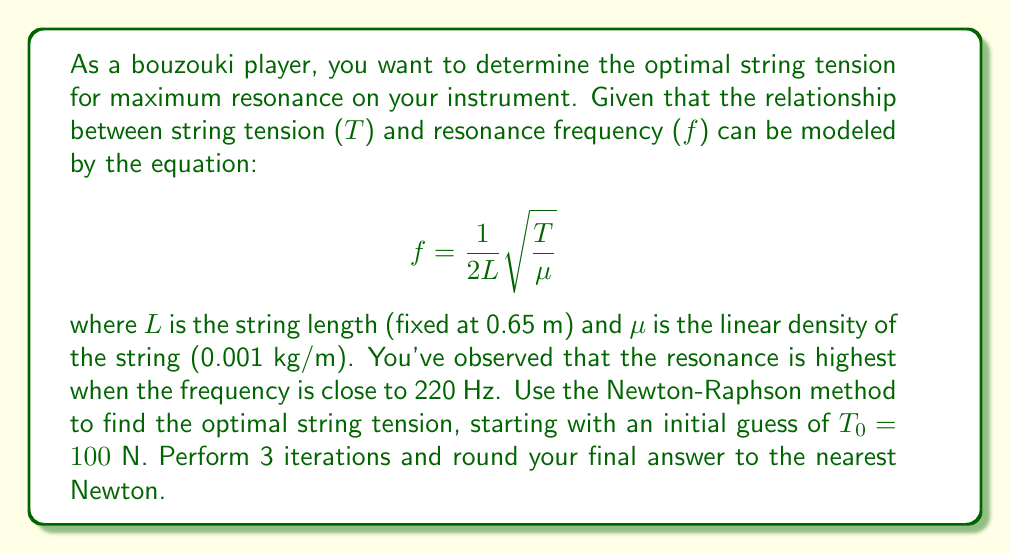Provide a solution to this math problem. To solve this problem using the Newton-Raphson method, we need to follow these steps:

1) First, we rearrange the equation to get it in the form $f(T) = 0$:

   $$f(T) = \frac{1}{2L}\sqrt{\frac{T}{\mu}} - 220 = 0$$

2) We then need to find the derivative of this function:

   $$f'(T) = \frac{1}{4L\sqrt{\mu T}}$$

3) The Newton-Raphson formula is:

   $$T_{n+1} = T_n - \frac{f(T_n)}{f'(T_n)}$$

4) Let's substitute our values:
   $L = 0.65$ m
   $\mu = 0.001$ kg/m
   Initial guess: $T_0 = 100$ N

5) Now we perform 3 iterations:

   Iteration 1:
   $$f(T_0) = \frac{1}{2(0.65)}\sqrt{\frac{100}{0.001}} - 220 = 119.23$$
   $$f'(T_0) = \frac{1}{4(0.65)\sqrt{0.001(100)}} = 0.9615$$
   $$T_1 = 100 - \frac{119.23}{0.9615} = -24.02$$

   Iteration 2:
   $$f(T_1) = \frac{1}{2(0.65)}\sqrt{\frac{|-24.02|}{0.001}} - 220 = -161.96$$
   $$f'(T_1) = \frac{1}{4(0.65)\sqrt{0.001(|-24.02|)}} = 1.9604$$
   $$T_2 = |-24.02| - \frac{-161.96}{1.9604} = 106.60$$

   Iteration 3:
   $$f(T_2) = \frac{1}{2(0.65)}\sqrt{\frac{106.60}{0.001}} - 220 = 3.37$$
   $$f'(T_2) = \frac{1}{4(0.65)\sqrt{0.001(106.60)}} = 0.9315$$
   $$T_3 = 106.60 - \frac{3.37}{0.9315} = 102.98$$

6) Rounding to the nearest Newton, we get 103 N.
Answer: 103 N 